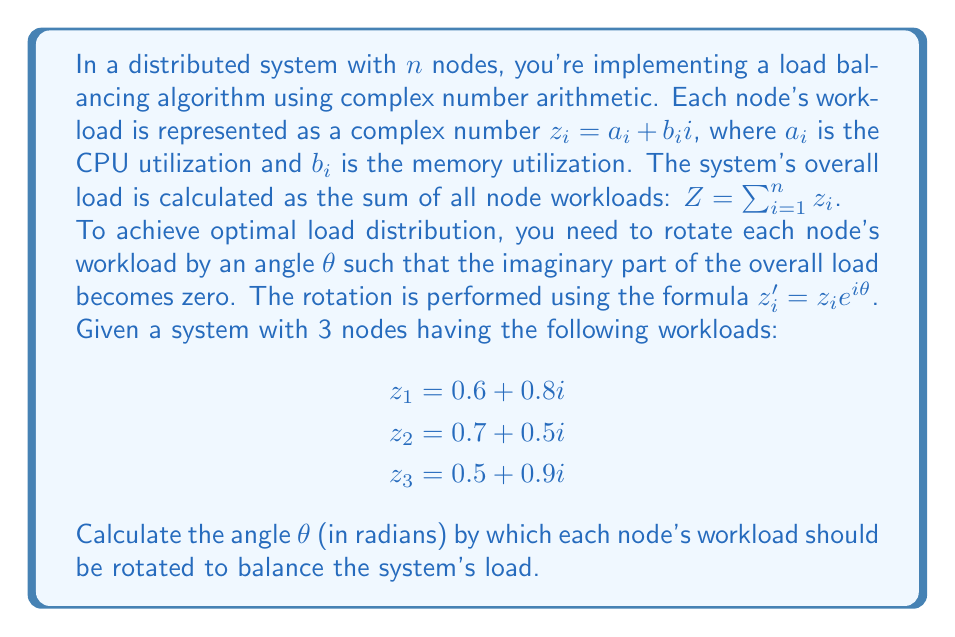Could you help me with this problem? Let's approach this step-by-step:

1) First, we calculate the overall load $Z$:
   $Z = z_1 + z_2 + z_3 = (0.6 + 0.8i) + (0.7 + 0.5i) + (0.5 + 0.9i)$
   $Z = 1.8 + 2.2i$

2) We want to rotate $Z$ so that its imaginary part becomes zero. This means:
   $Z e^{i\theta} = 1.8 + 2.2i$ (where $e^{i\theta} = \cos\theta + i\sin\theta$)

3) Expanding this:
   $(1.8 + 2.2i)(\cos\theta + i\sin\theta) = 1.8\cos\theta - 2.2\sin\theta + i(1.8\sin\theta + 2.2\cos\theta)$

4) For the imaginary part to be zero:
   $1.8\sin\theta + 2.2\cos\theta = 0$

5) Dividing both sides by $\cos\theta$ (assuming $\cos\theta \neq 0$):
   $1.8\tan\theta + 2.2 = 0$

6) Solving for $\tan\theta$:
   $\tan\theta = -\frac{2.2}{1.8} = -\frac{11}{9}$

7) Therefore:
   $\theta = \arctan(-\frac{11}{9})$

8) To get the final answer in radians:
   $\theta = -0.8881$ radians (rounded to 4 decimal places)

Note: We take the negative value because we want to rotate clockwise to move the imaginary part to zero.
Answer: $\theta = -0.8881$ radians 